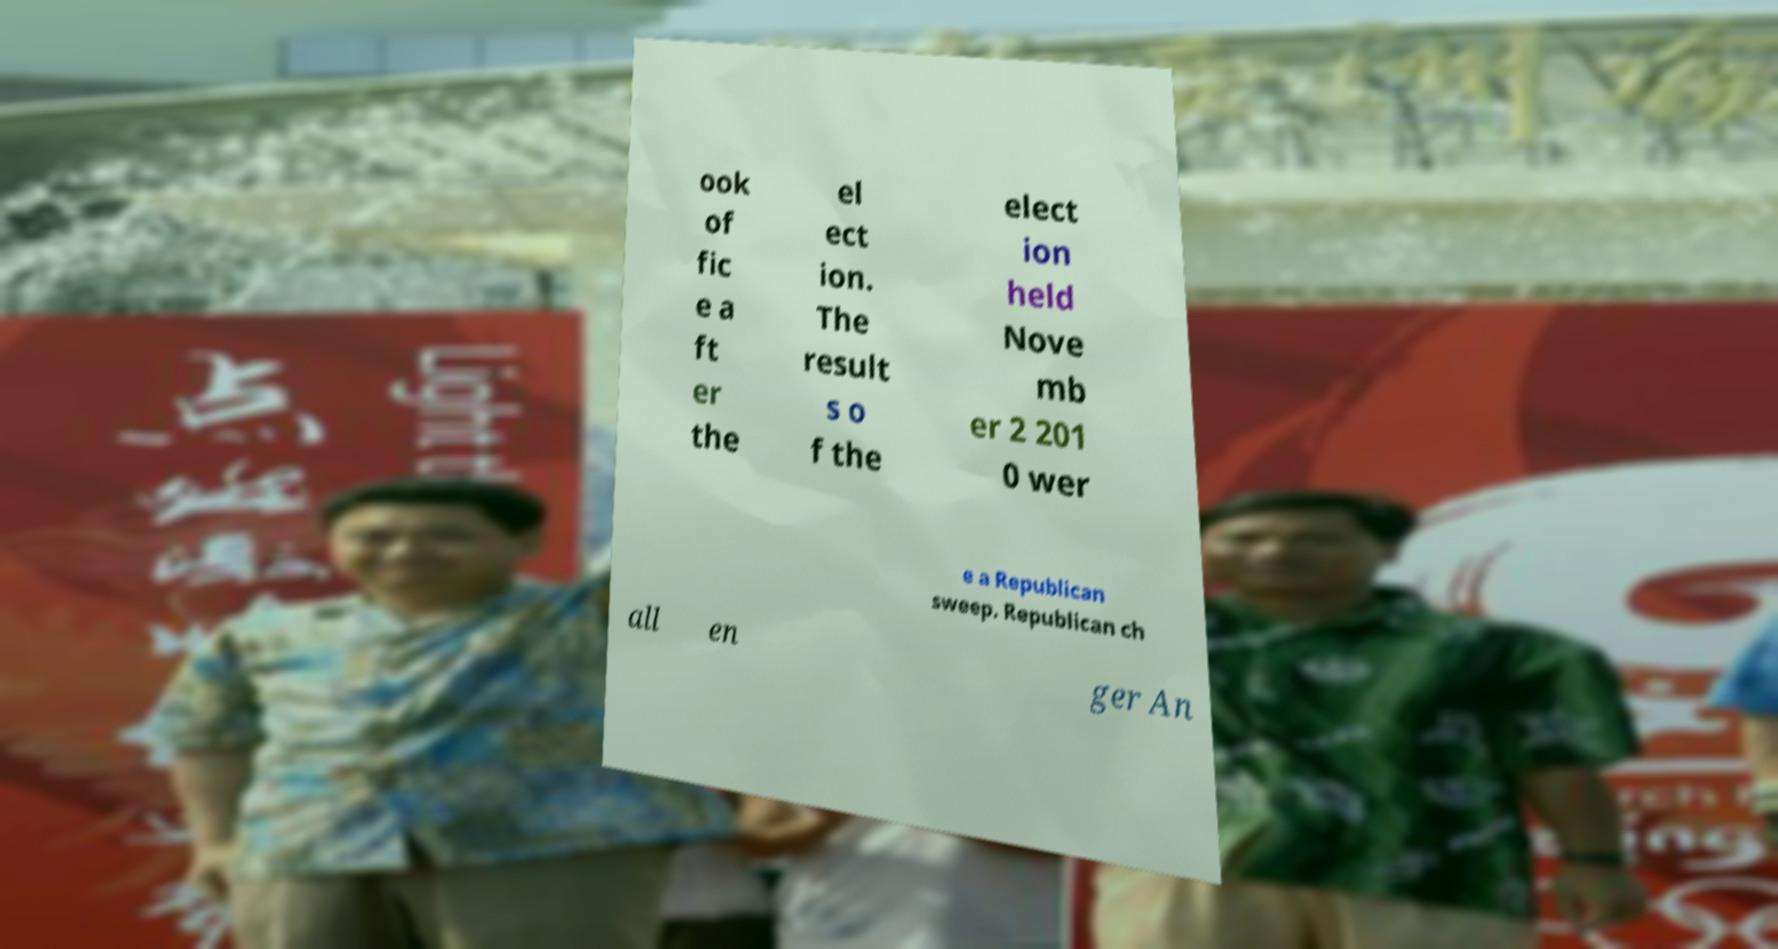Can you accurately transcribe the text from the provided image for me? ook of fic e a ft er the el ect ion. The result s o f the elect ion held Nove mb er 2 201 0 wer e a Republican sweep. Republican ch all en ger An 